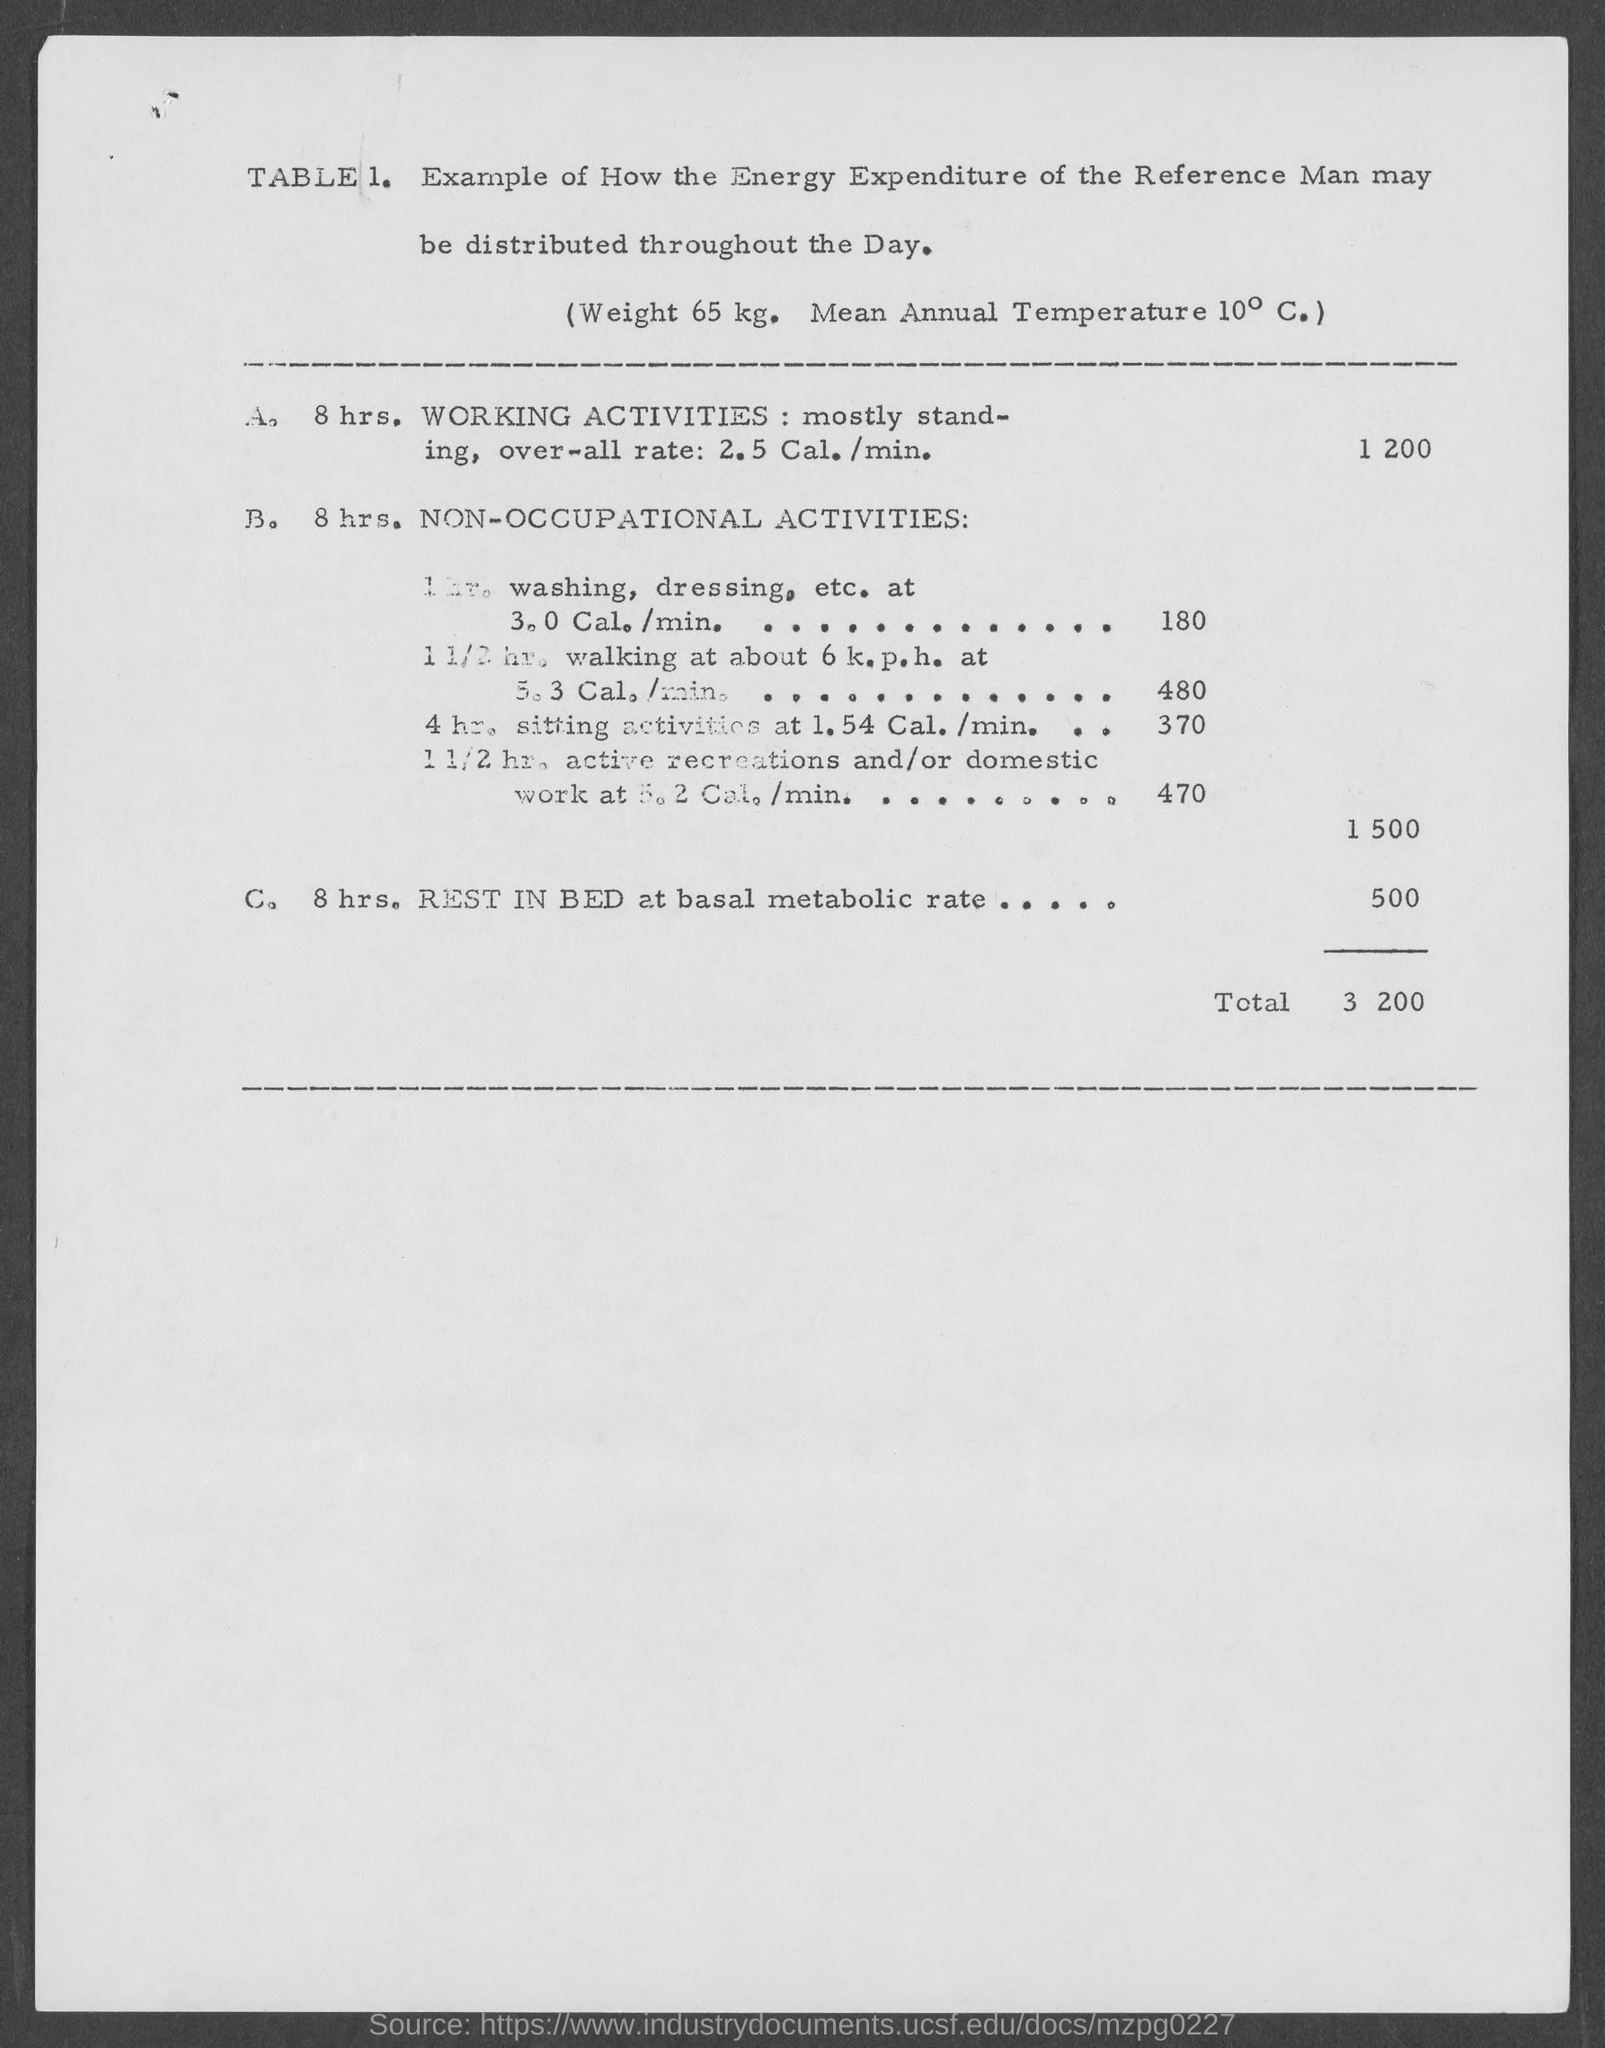What is the total amount ?
Your answer should be very brief. $3 200. 